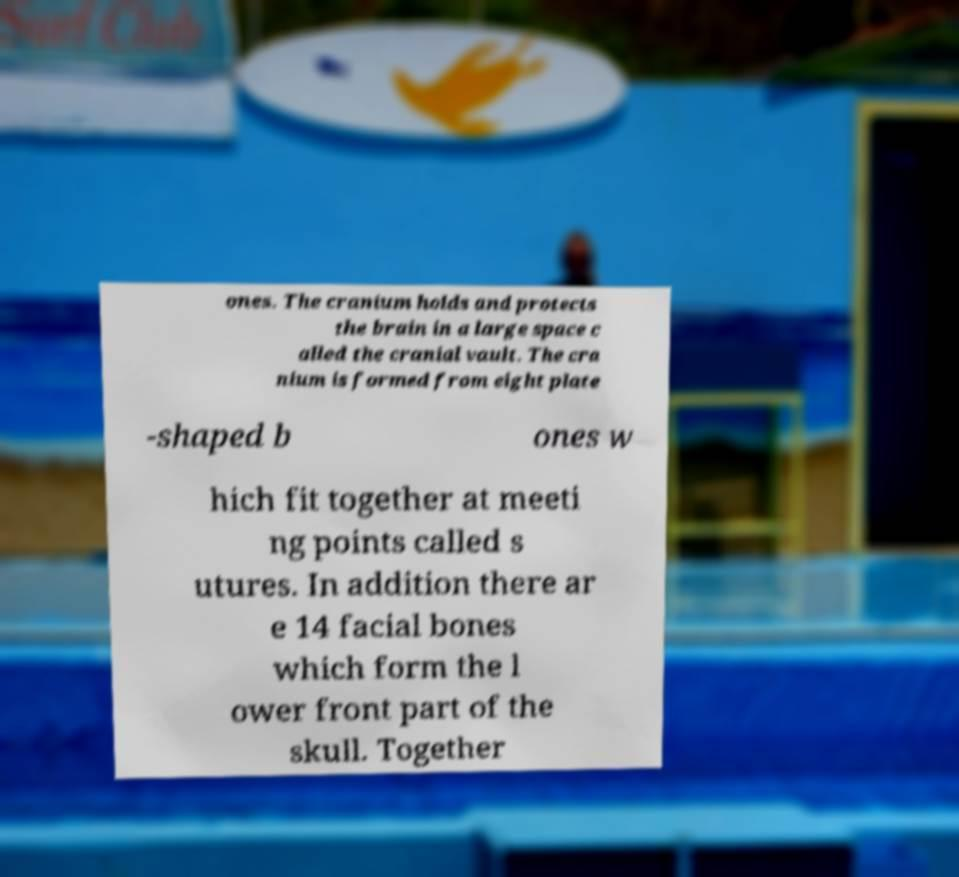There's text embedded in this image that I need extracted. Can you transcribe it verbatim? ones. The cranium holds and protects the brain in a large space c alled the cranial vault. The cra nium is formed from eight plate -shaped b ones w hich fit together at meeti ng points called s utures. In addition there ar e 14 facial bones which form the l ower front part of the skull. Together 